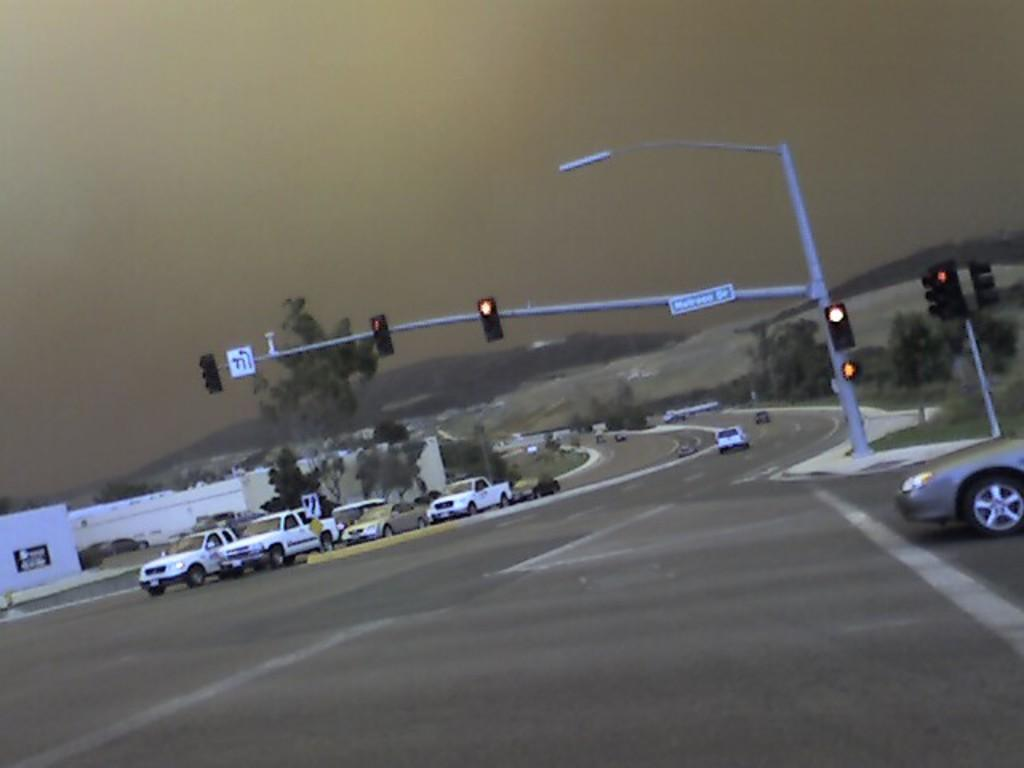What is the main object in the image that controls traffic? There is a traffic signal in the image. What type of vehicles can be seen on the road in the image? Vehicles are visible on the road in the image. What color are the trees in the image? The trees in the image have a green color. What color is the building in the image? The building in the image has a white color. What is the color of the sky in the image? The sky has a gray color in the image. What type of picture is hanging on the wall in the image? There is no mention of a picture hanging on the wall in the image; the facts provided only mention a traffic signal, vehicles, trees, a building, and the sky. 